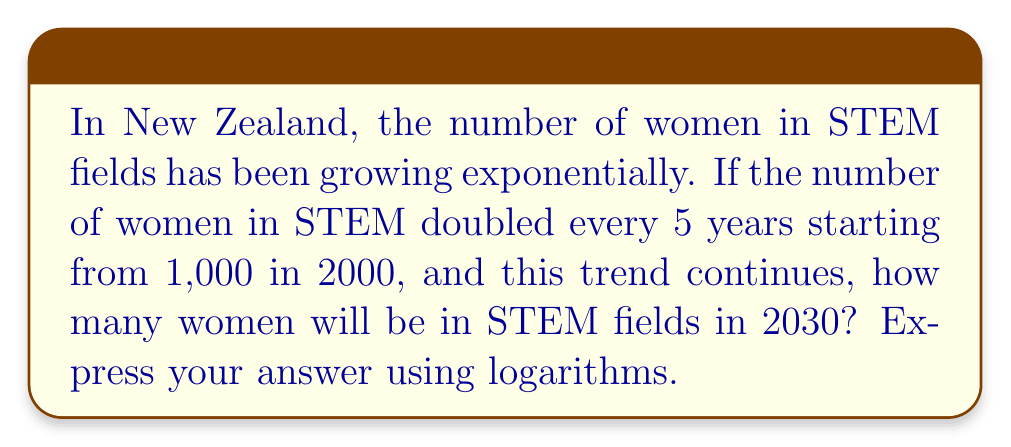Teach me how to tackle this problem. Let's approach this step-by-step:

1) First, we need to determine how many 5-year periods have passed from 2000 to 2030:
   $\frac{2030 - 2000}{5} = 6$ periods

2) We know that the number doubles every 5 years. This means we're dealing with exponential growth with a base of 2:
   $1000 \cdot 2^6$

3) Now, let's express this using logarithms. We want to find $x$ where:
   $x = 1000 \cdot 2^6$

4) Taking the logarithm of both sides (we'll use base 10 for simplicity):
   $\log x = \log(1000 \cdot 2^6)$

5) Using the logarithm product rule:
   $\log x = \log 1000 + \log(2^6)$

6) Simplify:
   $\log x = 3 + 6\log 2$

7) Therefore, the number of women in STEM fields in 2030 can be expressed as:
   $x = 10^{3 + 6\log 2}$

This logarithmic expression represents the exponential growth of women's participation in STEM fields in New Zealand from 2000 to 2030.
Answer: $10^{3 + 6\log 2}$ 